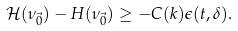Convert formula to latex. <formula><loc_0><loc_0><loc_500><loc_500>\mathcal { H } ( \nu _ { \vec { 0 } } ) - H ( \nu _ { \vec { 0 } } ) \geq - C ( k ) \epsilon ( t , \delta ) .</formula> 